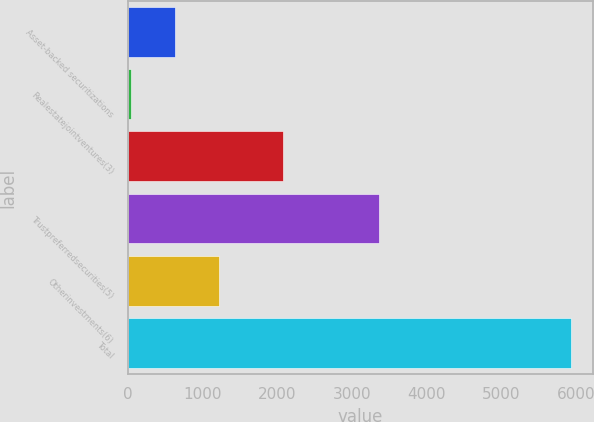<chart> <loc_0><loc_0><loc_500><loc_500><bar_chart><fcel>Asset-backed securitizations<fcel>Realestatejointventures(3)<fcel>Unnamed: 2<fcel>Trustpreferredsecurities(5)<fcel>Otherinvestments(6)<fcel>Total<nl><fcel>631.3<fcel>42<fcel>2080<fcel>3369<fcel>1220.6<fcel>5935<nl></chart> 